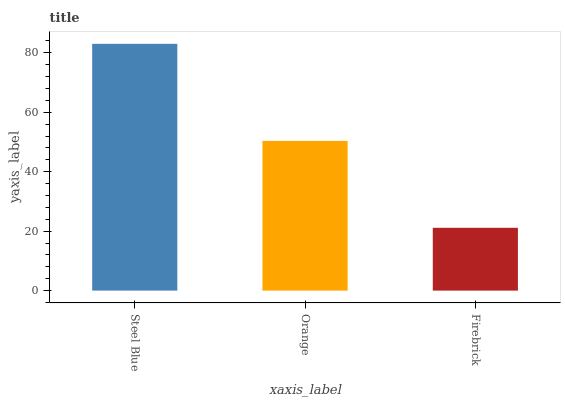Is Firebrick the minimum?
Answer yes or no. Yes. Is Steel Blue the maximum?
Answer yes or no. Yes. Is Orange the minimum?
Answer yes or no. No. Is Orange the maximum?
Answer yes or no. No. Is Steel Blue greater than Orange?
Answer yes or no. Yes. Is Orange less than Steel Blue?
Answer yes or no. Yes. Is Orange greater than Steel Blue?
Answer yes or no. No. Is Steel Blue less than Orange?
Answer yes or no. No. Is Orange the high median?
Answer yes or no. Yes. Is Orange the low median?
Answer yes or no. Yes. Is Steel Blue the high median?
Answer yes or no. No. Is Firebrick the low median?
Answer yes or no. No. 